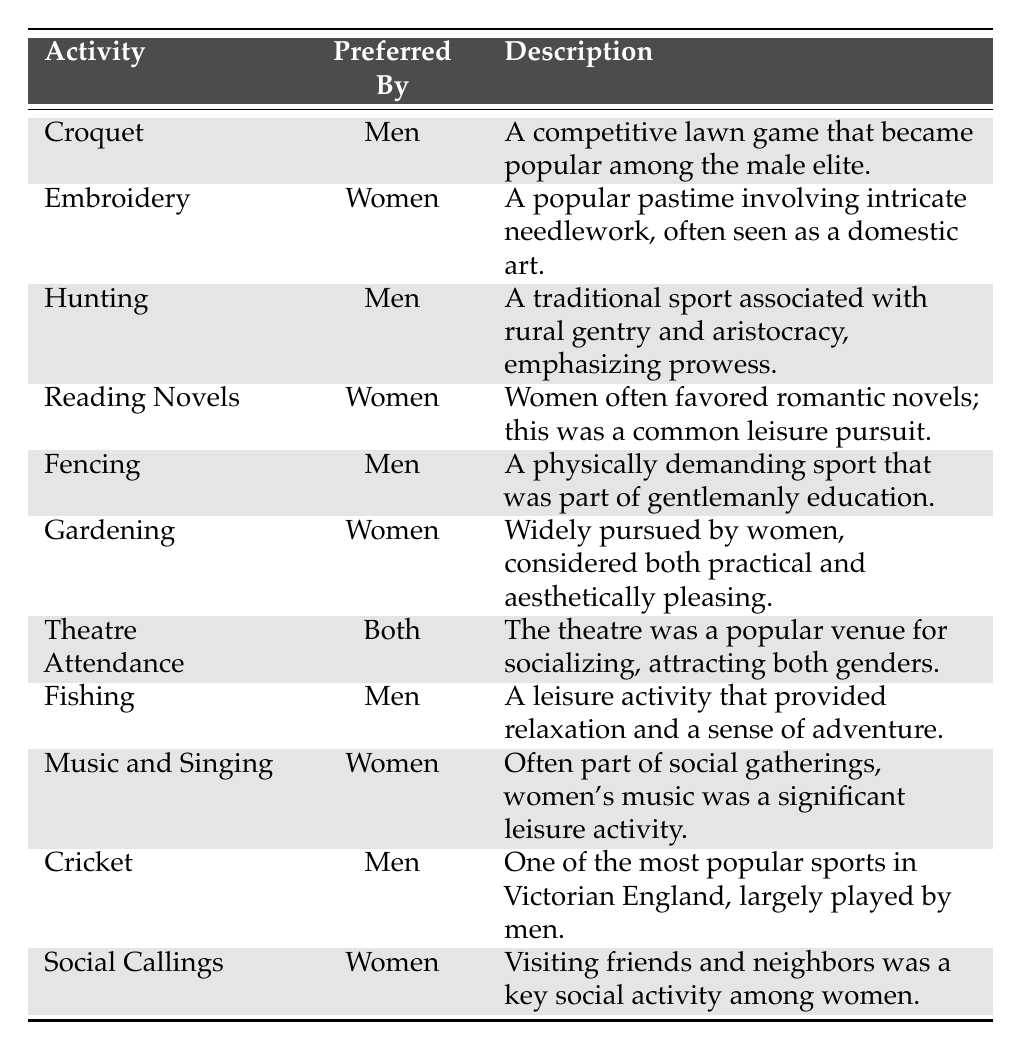What leisure activity is preferred by women? The table shows "Embroidery," "Reading Novels," "Gardening," "Music and Singing," and "Social Callings" as activities preferred by women.
Answer: Embroidery How many leisure activities are preferred by men? According to the table, the activities preferred by men are "Croquet," "Hunting," "Fencing," "Fishing," and "Cricket," totaling five activities.
Answer: 5 Is "Theatre Attendance" favored by one gender? The table states that "Theatre Attendance" is preferred by both men and women, indicating it is not limited to one gender.
Answer: No What are the descriptions for the leisure activities favored by women? The descriptions for women's activities are: "a popular pastime involving intricate needlework," "often favored romantic novels," "considered both practical and aesthetically pleasing," "part of social gatherings," and "a key social activity."
Answer: Various descriptions for women's activities Which activity is the only one listed that is preferred by both genders? The table indicates that "Theatre Attendance" is the only activity preferred by both men and women.
Answer: Theatre Attendance How many activities in total are listed in the table? There are a total of 11 activities listed in the table, with five favored by men, five favored by women, and one that is preferred by both.
Answer: 11 What is the difference in the number of leisure activities favored by men and women? Men have five activities, while women also have five activities. Thus, the difference is 0.
Answer: 0 Are any leisure activities exclusively favored by women? The table lists "Embroidery," "Reading Novels," "Gardening," "Music and Singing," and "Social Callings" as activities that are exclusively favored by women.
Answer: Yes Which male-preferred activity has a description emphasizing its competitive nature? "Croquet" as a competitive lawn game, is mentioned in its description, emphasizing its nature as a competition among the male elite.
Answer: Croquet Which leisure activity has the description that suggests it requires physical prowess? "Hunting" is described as a traditional sport that emphasizes prowess, indicating its physical demands.
Answer: Hunting What is the most common theme for activities preferred by women? The activities often center around domestic arts and social engagement, reflecting their roles in society during the Victorian era.
Answer: Domestic arts and social engagement What are the two leisure activities that suggest outdoor engagement? The activities "Hunting" and "Fishing" reflect outdoor engagement with nature, as indicated in their descriptions.
Answer: Hunting and Fishing 